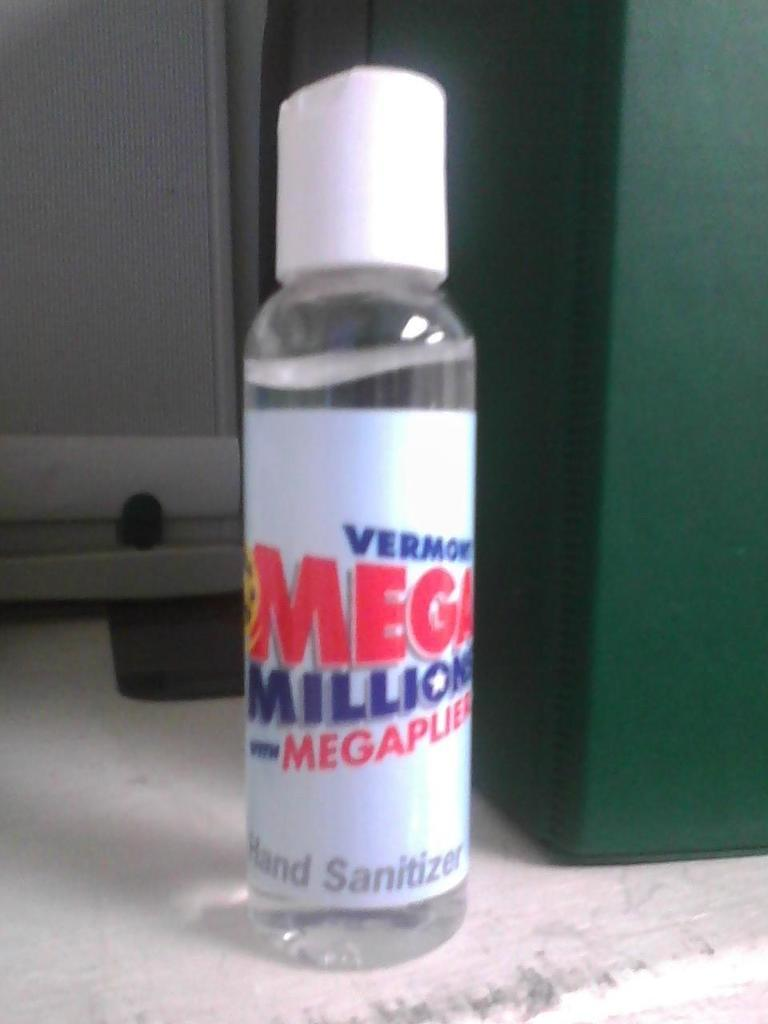<image>
Offer a succinct explanation of the picture presented. a clear small bottle of Mega Million hand sanitizer 